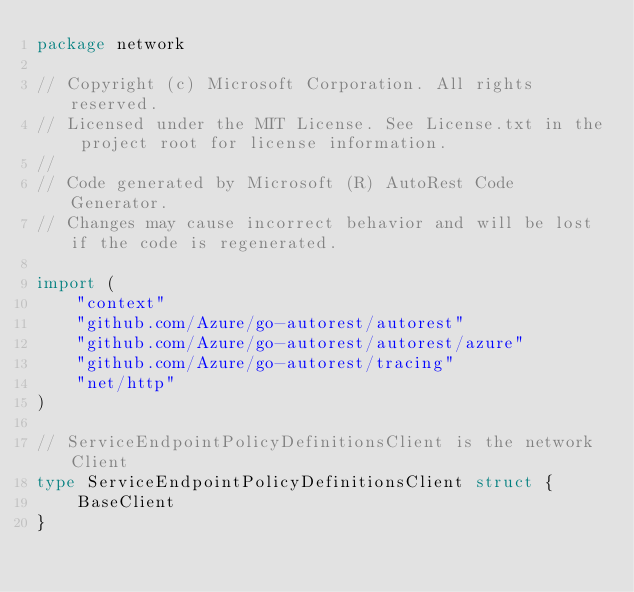<code> <loc_0><loc_0><loc_500><loc_500><_Go_>package network

// Copyright (c) Microsoft Corporation. All rights reserved.
// Licensed under the MIT License. See License.txt in the project root for license information.
//
// Code generated by Microsoft (R) AutoRest Code Generator.
// Changes may cause incorrect behavior and will be lost if the code is regenerated.

import (
	"context"
	"github.com/Azure/go-autorest/autorest"
	"github.com/Azure/go-autorest/autorest/azure"
	"github.com/Azure/go-autorest/tracing"
	"net/http"
)

// ServiceEndpointPolicyDefinitionsClient is the network Client
type ServiceEndpointPolicyDefinitionsClient struct {
	BaseClient
}
</code> 